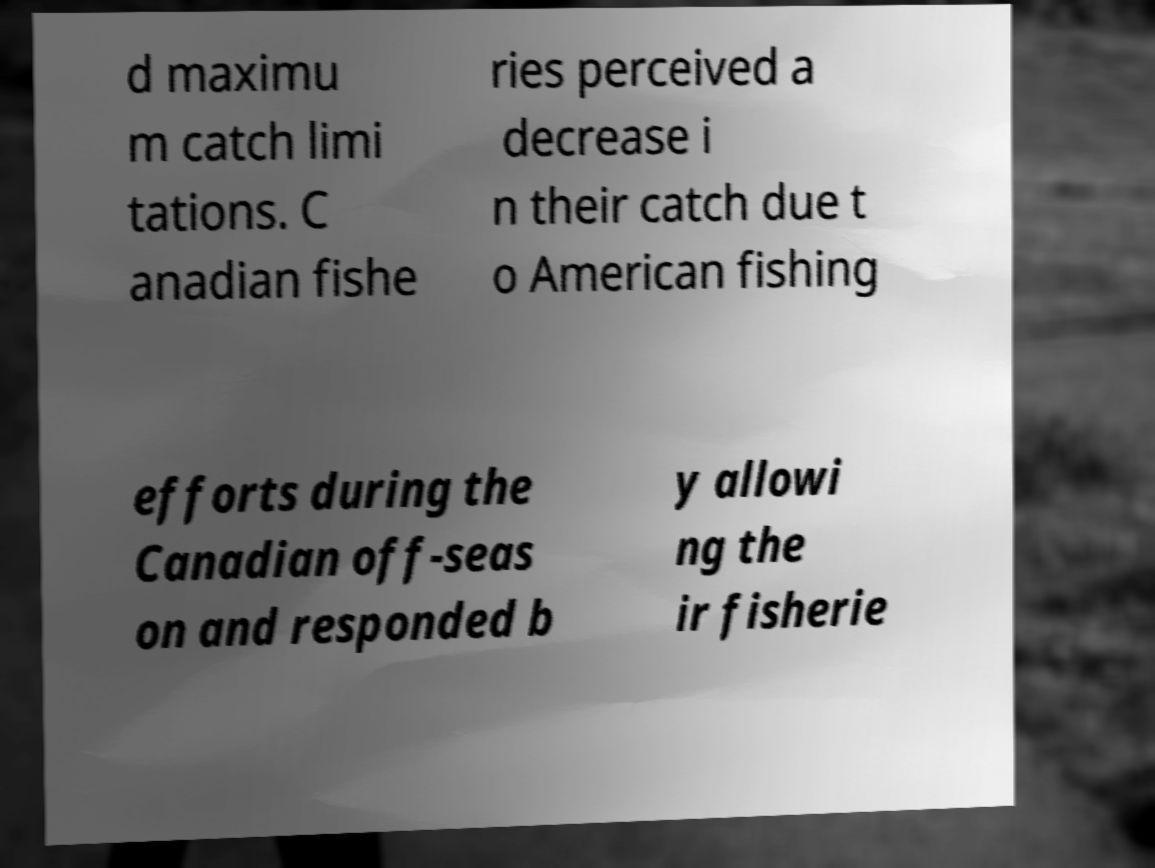I need the written content from this picture converted into text. Can you do that? d maximu m catch limi tations. C anadian fishe ries perceived a decrease i n their catch due t o American fishing efforts during the Canadian off-seas on and responded b y allowi ng the ir fisherie 